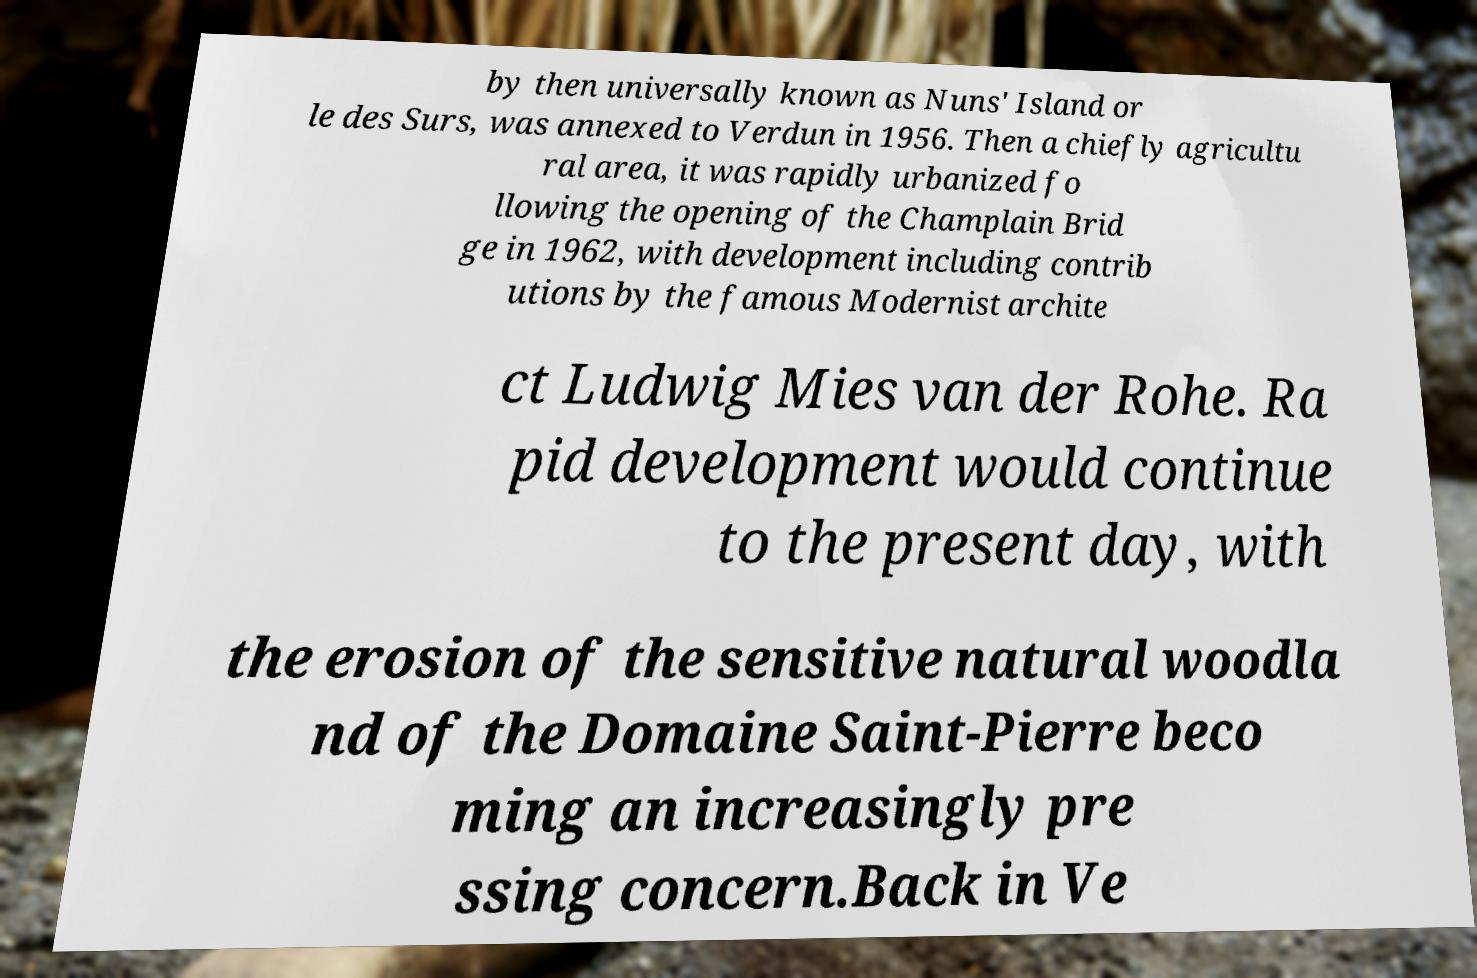Can you accurately transcribe the text from the provided image for me? by then universally known as Nuns' Island or le des Surs, was annexed to Verdun in 1956. Then a chiefly agricultu ral area, it was rapidly urbanized fo llowing the opening of the Champlain Brid ge in 1962, with development including contrib utions by the famous Modernist archite ct Ludwig Mies van der Rohe. Ra pid development would continue to the present day, with the erosion of the sensitive natural woodla nd of the Domaine Saint-Pierre beco ming an increasingly pre ssing concern.Back in Ve 